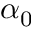<formula> <loc_0><loc_0><loc_500><loc_500>\alpha _ { 0 }</formula> 